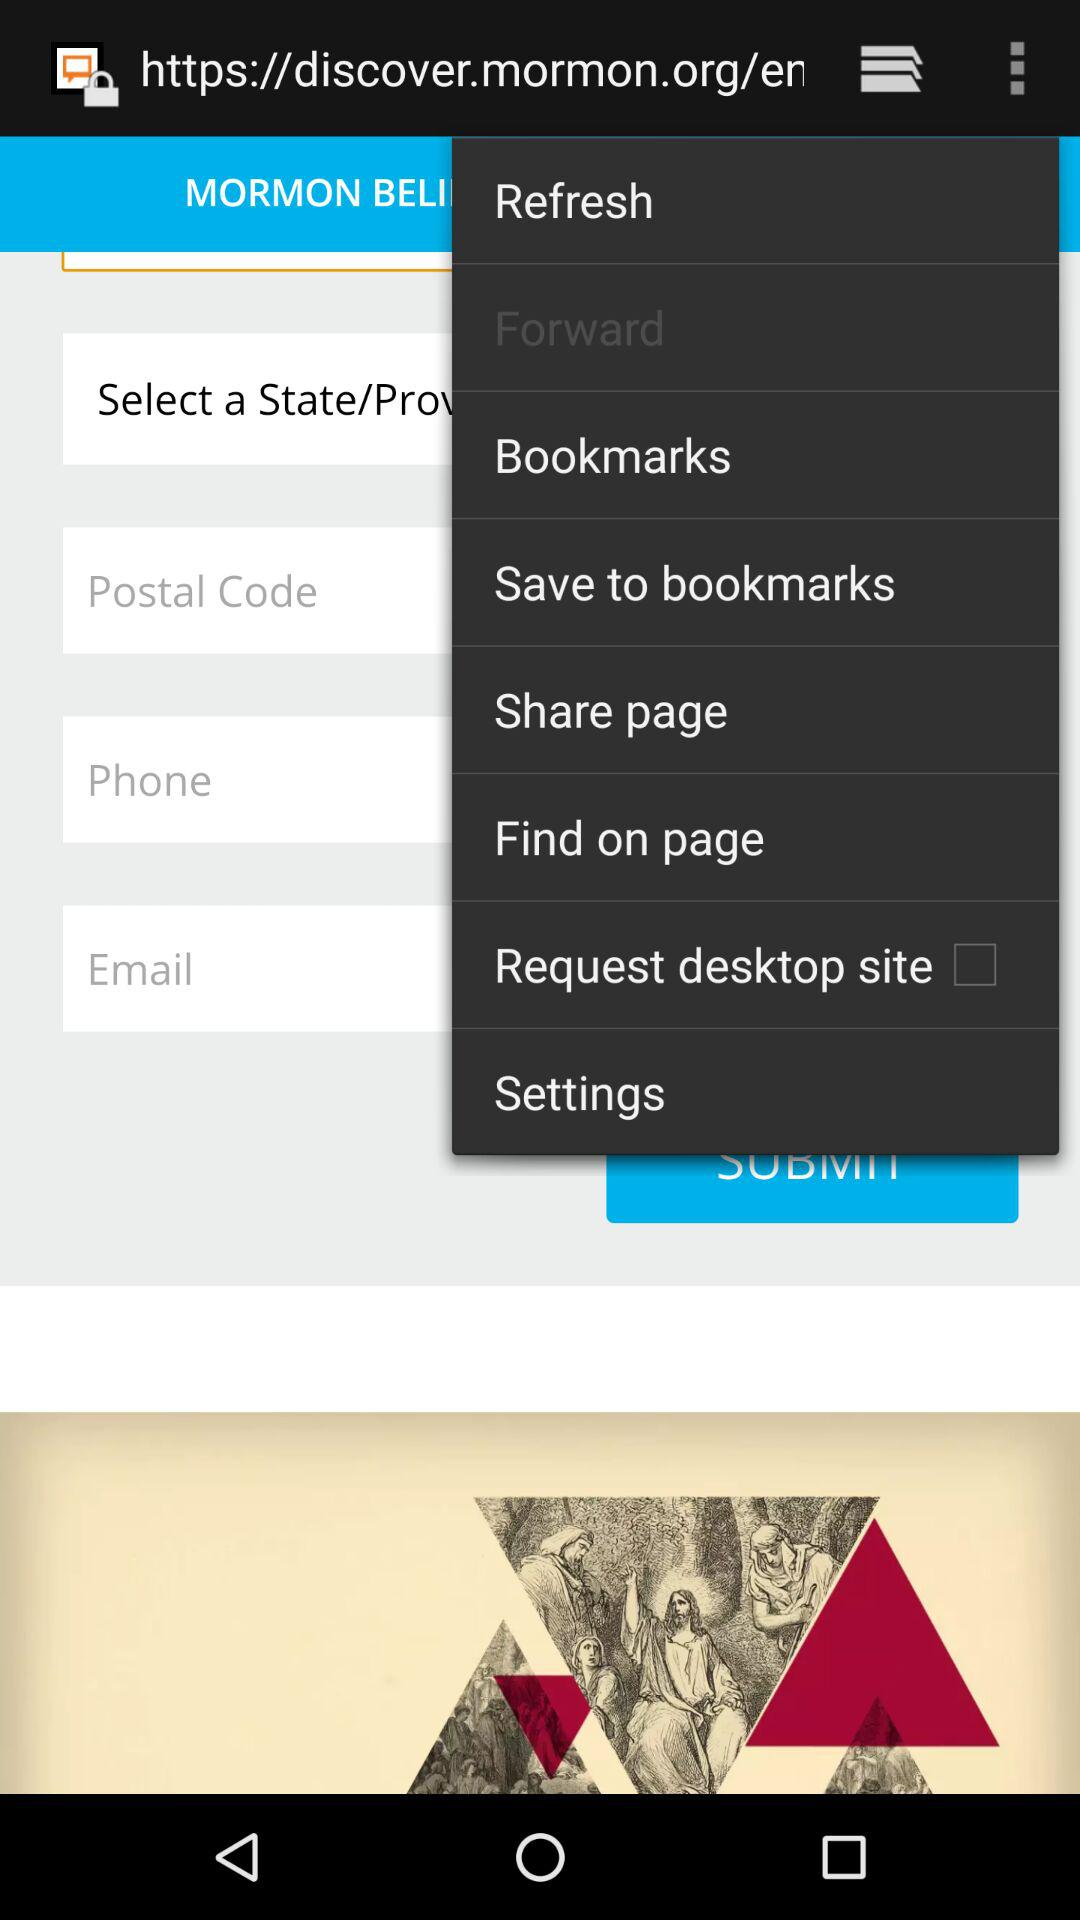Is "Request desktop site" checked or not? "Request desktop site" is not checked. 